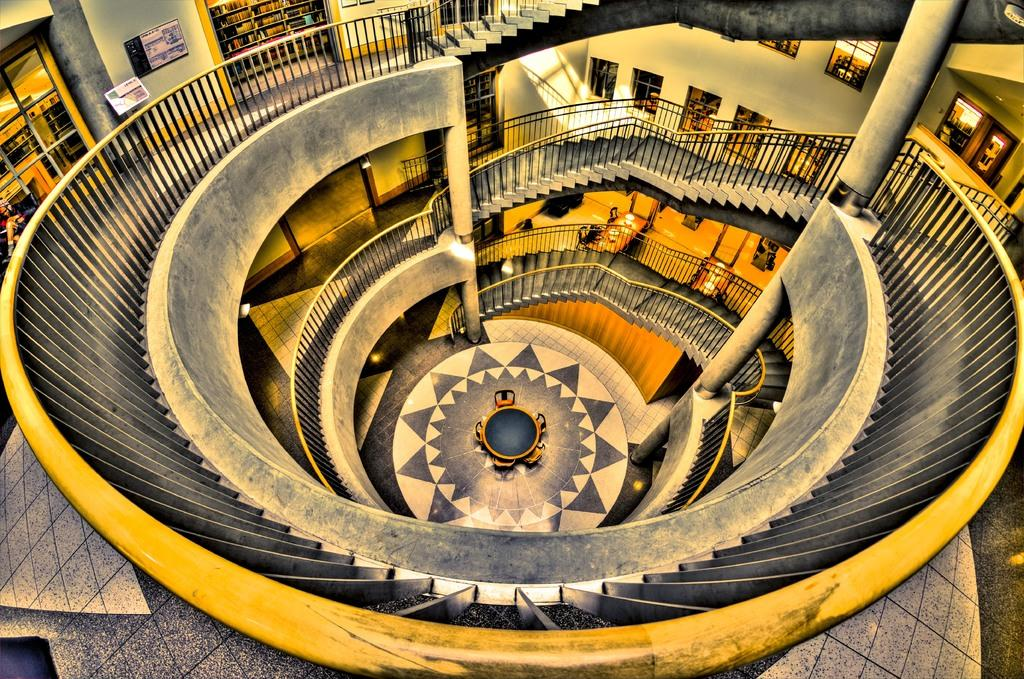What type of location is depicted in the image? The image is an inside view of a building. What architectural features can be seen in the image? There are railings, stairs, walls, pillars, and floors visible in the image. What lighting elements are present in the image? There are lights in the image. What furniture items can be seen in the image? There are boards, tables, and chairs in the image. What type of objects are made of glass in the image? There are glass objects in the image. Can you tell me which mother is playing chess with her child in the image? There is no mother or child playing chess in the image; it does not depict a chess game. How many eyes can be seen on the user's face in the image? There is no face visible in the image, so it is not possible to determine the number of eyes. 